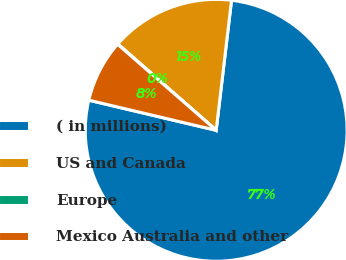<chart> <loc_0><loc_0><loc_500><loc_500><pie_chart><fcel>( in millions)<fcel>US and Canada<fcel>Europe<fcel>Mexico Australia and other<nl><fcel>76.83%<fcel>15.4%<fcel>0.05%<fcel>7.72%<nl></chart> 